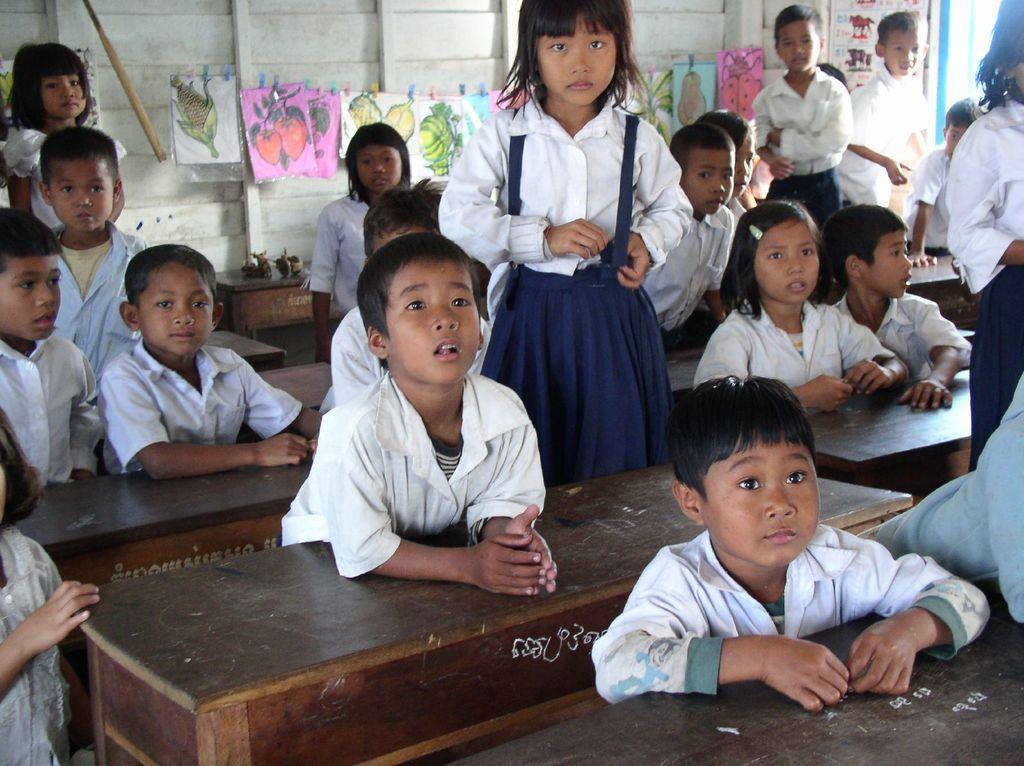Could you give a brief overview of what you see in this image? In this picture we can observe number of children sitting on the benches. There are boys and girls wearing white and blue color school uniforms. In the background there is a wire to which white pink and blue color papers were clipped. In the background there is a white color wall. 